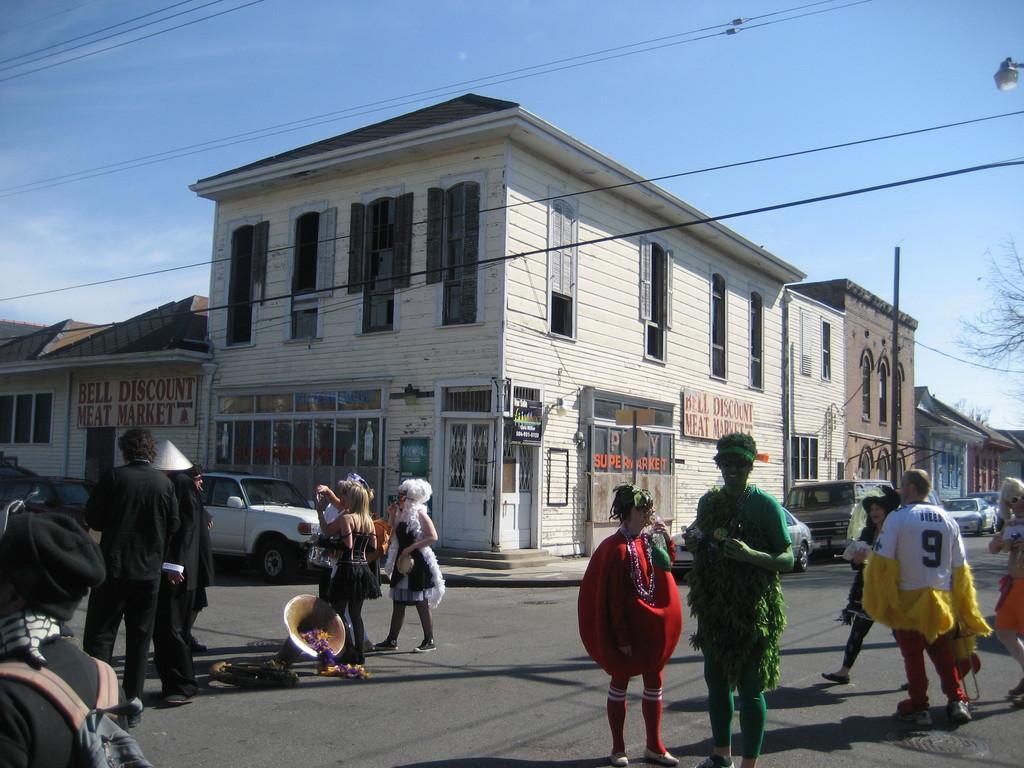Please provide a concise description of this image. In this picture I can see the shop building beside to that there are three buildings and cars in front of buildings. Also there are people with different costumes on the road. 